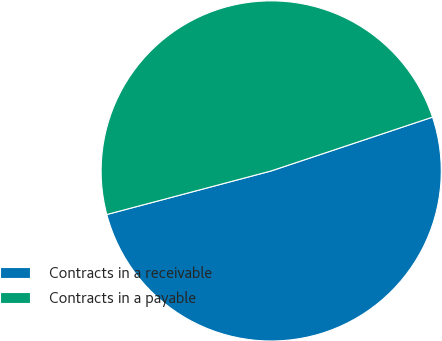Convert chart. <chart><loc_0><loc_0><loc_500><loc_500><pie_chart><fcel>Contracts in a receivable<fcel>Contracts in a payable<nl><fcel>51.0%<fcel>49.0%<nl></chart> 